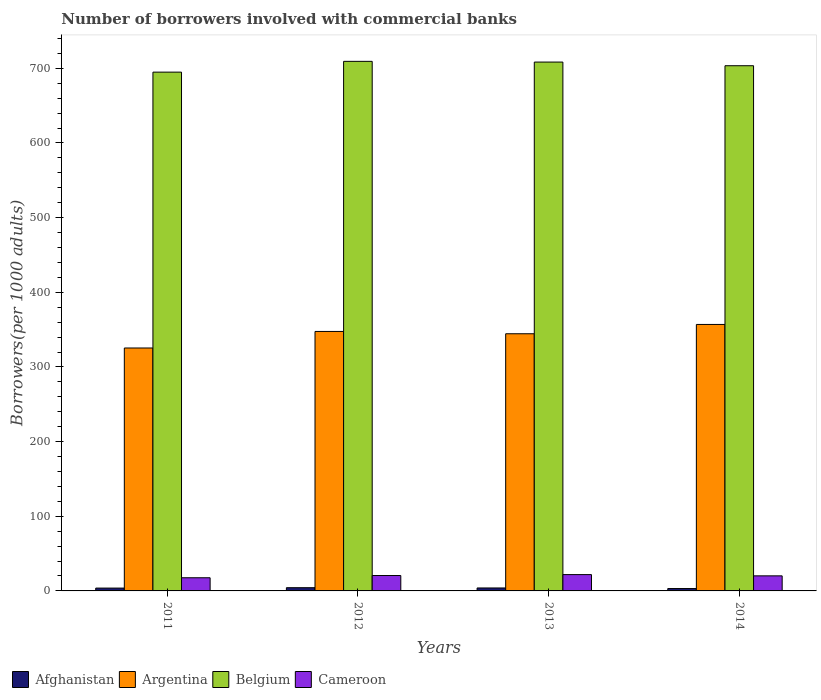Are the number of bars on each tick of the X-axis equal?
Your answer should be very brief. Yes. What is the number of borrowers involved with commercial banks in Belgium in 2012?
Ensure brevity in your answer.  709.35. Across all years, what is the maximum number of borrowers involved with commercial banks in Belgium?
Ensure brevity in your answer.  709.35. Across all years, what is the minimum number of borrowers involved with commercial banks in Belgium?
Your response must be concise. 694.92. In which year was the number of borrowers involved with commercial banks in Argentina minimum?
Provide a succinct answer. 2011. What is the total number of borrowers involved with commercial banks in Argentina in the graph?
Keep it short and to the point. 1374.36. What is the difference between the number of borrowers involved with commercial banks in Cameroon in 2011 and that in 2013?
Offer a terse response. -4.23. What is the difference between the number of borrowers involved with commercial banks in Argentina in 2011 and the number of borrowers involved with commercial banks in Belgium in 2014?
Keep it short and to the point. -378.09. What is the average number of borrowers involved with commercial banks in Belgium per year?
Your answer should be very brief. 704.03. In the year 2012, what is the difference between the number of borrowers involved with commercial banks in Afghanistan and number of borrowers involved with commercial banks in Belgium?
Your answer should be compact. -705.03. In how many years, is the number of borrowers involved with commercial banks in Argentina greater than 460?
Your answer should be very brief. 0. What is the ratio of the number of borrowers involved with commercial banks in Cameroon in 2011 to that in 2012?
Your answer should be compact. 0.85. Is the difference between the number of borrowers involved with commercial banks in Afghanistan in 2011 and 2012 greater than the difference between the number of borrowers involved with commercial banks in Belgium in 2011 and 2012?
Your answer should be compact. Yes. What is the difference between the highest and the second highest number of borrowers involved with commercial banks in Cameroon?
Provide a short and direct response. 1.23. What is the difference between the highest and the lowest number of borrowers involved with commercial banks in Afghanistan?
Your answer should be compact. 1.12. In how many years, is the number of borrowers involved with commercial banks in Argentina greater than the average number of borrowers involved with commercial banks in Argentina taken over all years?
Ensure brevity in your answer.  3. Is the sum of the number of borrowers involved with commercial banks in Argentina in 2011 and 2014 greater than the maximum number of borrowers involved with commercial banks in Afghanistan across all years?
Provide a short and direct response. Yes. What does the 3rd bar from the left in 2013 represents?
Your answer should be compact. Belgium. What does the 4th bar from the right in 2012 represents?
Offer a terse response. Afghanistan. How many bars are there?
Your answer should be compact. 16. What is the difference between two consecutive major ticks on the Y-axis?
Your response must be concise. 100. Are the values on the major ticks of Y-axis written in scientific E-notation?
Your answer should be very brief. No. Does the graph contain any zero values?
Provide a short and direct response. No. Does the graph contain grids?
Your answer should be compact. No. How many legend labels are there?
Give a very brief answer. 4. What is the title of the graph?
Make the answer very short. Number of borrowers involved with commercial banks. Does "Belgium" appear as one of the legend labels in the graph?
Offer a very short reply. Yes. What is the label or title of the Y-axis?
Provide a short and direct response. Borrowers(per 1000 adults). What is the Borrowers(per 1000 adults) of Afghanistan in 2011?
Your answer should be very brief. 3.79. What is the Borrowers(per 1000 adults) in Argentina in 2011?
Provide a short and direct response. 325.39. What is the Borrowers(per 1000 adults) of Belgium in 2011?
Provide a short and direct response. 694.92. What is the Borrowers(per 1000 adults) of Cameroon in 2011?
Offer a very short reply. 17.62. What is the Borrowers(per 1000 adults) in Afghanistan in 2012?
Offer a very short reply. 4.31. What is the Borrowers(per 1000 adults) of Argentina in 2012?
Keep it short and to the point. 347.56. What is the Borrowers(per 1000 adults) in Belgium in 2012?
Your response must be concise. 709.35. What is the Borrowers(per 1000 adults) of Cameroon in 2012?
Your response must be concise. 20.63. What is the Borrowers(per 1000 adults) of Afghanistan in 2013?
Make the answer very short. 3.96. What is the Borrowers(per 1000 adults) in Argentina in 2013?
Give a very brief answer. 344.47. What is the Borrowers(per 1000 adults) of Belgium in 2013?
Make the answer very short. 708.39. What is the Borrowers(per 1000 adults) of Cameroon in 2013?
Provide a short and direct response. 21.86. What is the Borrowers(per 1000 adults) of Afghanistan in 2014?
Offer a terse response. 3.2. What is the Borrowers(per 1000 adults) of Argentina in 2014?
Make the answer very short. 356.93. What is the Borrowers(per 1000 adults) of Belgium in 2014?
Ensure brevity in your answer.  703.48. What is the Borrowers(per 1000 adults) of Cameroon in 2014?
Keep it short and to the point. 20.18. Across all years, what is the maximum Borrowers(per 1000 adults) of Afghanistan?
Ensure brevity in your answer.  4.31. Across all years, what is the maximum Borrowers(per 1000 adults) in Argentina?
Offer a very short reply. 356.93. Across all years, what is the maximum Borrowers(per 1000 adults) in Belgium?
Your response must be concise. 709.35. Across all years, what is the maximum Borrowers(per 1000 adults) in Cameroon?
Your answer should be very brief. 21.86. Across all years, what is the minimum Borrowers(per 1000 adults) in Afghanistan?
Give a very brief answer. 3.2. Across all years, what is the minimum Borrowers(per 1000 adults) in Argentina?
Provide a succinct answer. 325.39. Across all years, what is the minimum Borrowers(per 1000 adults) of Belgium?
Your answer should be compact. 694.92. Across all years, what is the minimum Borrowers(per 1000 adults) in Cameroon?
Make the answer very short. 17.62. What is the total Borrowers(per 1000 adults) of Afghanistan in the graph?
Keep it short and to the point. 15.26. What is the total Borrowers(per 1000 adults) in Argentina in the graph?
Your answer should be very brief. 1374.36. What is the total Borrowers(per 1000 adults) in Belgium in the graph?
Provide a succinct answer. 2816.13. What is the total Borrowers(per 1000 adults) in Cameroon in the graph?
Your answer should be compact. 80.29. What is the difference between the Borrowers(per 1000 adults) of Afghanistan in 2011 and that in 2012?
Your answer should be very brief. -0.52. What is the difference between the Borrowers(per 1000 adults) in Argentina in 2011 and that in 2012?
Keep it short and to the point. -22.17. What is the difference between the Borrowers(per 1000 adults) of Belgium in 2011 and that in 2012?
Provide a short and direct response. -14.43. What is the difference between the Borrowers(per 1000 adults) of Cameroon in 2011 and that in 2012?
Provide a succinct answer. -3.01. What is the difference between the Borrowers(per 1000 adults) in Afghanistan in 2011 and that in 2013?
Your answer should be compact. -0.16. What is the difference between the Borrowers(per 1000 adults) in Argentina in 2011 and that in 2013?
Your response must be concise. -19.08. What is the difference between the Borrowers(per 1000 adults) of Belgium in 2011 and that in 2013?
Keep it short and to the point. -13.48. What is the difference between the Borrowers(per 1000 adults) of Cameroon in 2011 and that in 2013?
Offer a very short reply. -4.23. What is the difference between the Borrowers(per 1000 adults) in Afghanistan in 2011 and that in 2014?
Provide a short and direct response. 0.6. What is the difference between the Borrowers(per 1000 adults) of Argentina in 2011 and that in 2014?
Ensure brevity in your answer.  -31.54. What is the difference between the Borrowers(per 1000 adults) of Belgium in 2011 and that in 2014?
Ensure brevity in your answer.  -8.56. What is the difference between the Borrowers(per 1000 adults) in Cameroon in 2011 and that in 2014?
Your answer should be compact. -2.56. What is the difference between the Borrowers(per 1000 adults) of Afghanistan in 2012 and that in 2013?
Your answer should be compact. 0.36. What is the difference between the Borrowers(per 1000 adults) of Argentina in 2012 and that in 2013?
Your answer should be compact. 3.09. What is the difference between the Borrowers(per 1000 adults) of Belgium in 2012 and that in 2013?
Offer a very short reply. 0.95. What is the difference between the Borrowers(per 1000 adults) in Cameroon in 2012 and that in 2013?
Your answer should be very brief. -1.23. What is the difference between the Borrowers(per 1000 adults) in Afghanistan in 2012 and that in 2014?
Make the answer very short. 1.12. What is the difference between the Borrowers(per 1000 adults) in Argentina in 2012 and that in 2014?
Offer a terse response. -9.37. What is the difference between the Borrowers(per 1000 adults) of Belgium in 2012 and that in 2014?
Your response must be concise. 5.87. What is the difference between the Borrowers(per 1000 adults) in Cameroon in 2012 and that in 2014?
Your answer should be compact. 0.45. What is the difference between the Borrowers(per 1000 adults) of Afghanistan in 2013 and that in 2014?
Provide a succinct answer. 0.76. What is the difference between the Borrowers(per 1000 adults) of Argentina in 2013 and that in 2014?
Ensure brevity in your answer.  -12.46. What is the difference between the Borrowers(per 1000 adults) of Belgium in 2013 and that in 2014?
Offer a terse response. 4.92. What is the difference between the Borrowers(per 1000 adults) of Cameroon in 2013 and that in 2014?
Offer a very short reply. 1.68. What is the difference between the Borrowers(per 1000 adults) in Afghanistan in 2011 and the Borrowers(per 1000 adults) in Argentina in 2012?
Give a very brief answer. -343.76. What is the difference between the Borrowers(per 1000 adults) of Afghanistan in 2011 and the Borrowers(per 1000 adults) of Belgium in 2012?
Offer a very short reply. -705.55. What is the difference between the Borrowers(per 1000 adults) in Afghanistan in 2011 and the Borrowers(per 1000 adults) in Cameroon in 2012?
Your answer should be very brief. -16.84. What is the difference between the Borrowers(per 1000 adults) of Argentina in 2011 and the Borrowers(per 1000 adults) of Belgium in 2012?
Provide a short and direct response. -383.95. What is the difference between the Borrowers(per 1000 adults) in Argentina in 2011 and the Borrowers(per 1000 adults) in Cameroon in 2012?
Provide a succinct answer. 304.76. What is the difference between the Borrowers(per 1000 adults) of Belgium in 2011 and the Borrowers(per 1000 adults) of Cameroon in 2012?
Your answer should be compact. 674.28. What is the difference between the Borrowers(per 1000 adults) of Afghanistan in 2011 and the Borrowers(per 1000 adults) of Argentina in 2013?
Ensure brevity in your answer.  -340.68. What is the difference between the Borrowers(per 1000 adults) of Afghanistan in 2011 and the Borrowers(per 1000 adults) of Belgium in 2013?
Your response must be concise. -704.6. What is the difference between the Borrowers(per 1000 adults) in Afghanistan in 2011 and the Borrowers(per 1000 adults) in Cameroon in 2013?
Provide a succinct answer. -18.06. What is the difference between the Borrowers(per 1000 adults) in Argentina in 2011 and the Borrowers(per 1000 adults) in Belgium in 2013?
Your answer should be compact. -383. What is the difference between the Borrowers(per 1000 adults) in Argentina in 2011 and the Borrowers(per 1000 adults) in Cameroon in 2013?
Your answer should be compact. 303.53. What is the difference between the Borrowers(per 1000 adults) of Belgium in 2011 and the Borrowers(per 1000 adults) of Cameroon in 2013?
Offer a very short reply. 673.06. What is the difference between the Borrowers(per 1000 adults) in Afghanistan in 2011 and the Borrowers(per 1000 adults) in Argentina in 2014?
Offer a very short reply. -353.14. What is the difference between the Borrowers(per 1000 adults) in Afghanistan in 2011 and the Borrowers(per 1000 adults) in Belgium in 2014?
Offer a very short reply. -699.68. What is the difference between the Borrowers(per 1000 adults) of Afghanistan in 2011 and the Borrowers(per 1000 adults) of Cameroon in 2014?
Offer a very short reply. -16.39. What is the difference between the Borrowers(per 1000 adults) of Argentina in 2011 and the Borrowers(per 1000 adults) of Belgium in 2014?
Your answer should be compact. -378.09. What is the difference between the Borrowers(per 1000 adults) in Argentina in 2011 and the Borrowers(per 1000 adults) in Cameroon in 2014?
Your answer should be compact. 305.21. What is the difference between the Borrowers(per 1000 adults) in Belgium in 2011 and the Borrowers(per 1000 adults) in Cameroon in 2014?
Keep it short and to the point. 674.73. What is the difference between the Borrowers(per 1000 adults) of Afghanistan in 2012 and the Borrowers(per 1000 adults) of Argentina in 2013?
Give a very brief answer. -340.16. What is the difference between the Borrowers(per 1000 adults) in Afghanistan in 2012 and the Borrowers(per 1000 adults) in Belgium in 2013?
Offer a very short reply. -704.08. What is the difference between the Borrowers(per 1000 adults) of Afghanistan in 2012 and the Borrowers(per 1000 adults) of Cameroon in 2013?
Provide a succinct answer. -17.54. What is the difference between the Borrowers(per 1000 adults) in Argentina in 2012 and the Borrowers(per 1000 adults) in Belgium in 2013?
Make the answer very short. -360.83. What is the difference between the Borrowers(per 1000 adults) of Argentina in 2012 and the Borrowers(per 1000 adults) of Cameroon in 2013?
Your answer should be very brief. 325.7. What is the difference between the Borrowers(per 1000 adults) in Belgium in 2012 and the Borrowers(per 1000 adults) in Cameroon in 2013?
Make the answer very short. 687.49. What is the difference between the Borrowers(per 1000 adults) in Afghanistan in 2012 and the Borrowers(per 1000 adults) in Argentina in 2014?
Offer a very short reply. -352.62. What is the difference between the Borrowers(per 1000 adults) of Afghanistan in 2012 and the Borrowers(per 1000 adults) of Belgium in 2014?
Offer a very short reply. -699.17. What is the difference between the Borrowers(per 1000 adults) of Afghanistan in 2012 and the Borrowers(per 1000 adults) of Cameroon in 2014?
Give a very brief answer. -15.87. What is the difference between the Borrowers(per 1000 adults) of Argentina in 2012 and the Borrowers(per 1000 adults) of Belgium in 2014?
Make the answer very short. -355.92. What is the difference between the Borrowers(per 1000 adults) in Argentina in 2012 and the Borrowers(per 1000 adults) in Cameroon in 2014?
Provide a succinct answer. 327.38. What is the difference between the Borrowers(per 1000 adults) of Belgium in 2012 and the Borrowers(per 1000 adults) of Cameroon in 2014?
Your response must be concise. 689.16. What is the difference between the Borrowers(per 1000 adults) in Afghanistan in 2013 and the Borrowers(per 1000 adults) in Argentina in 2014?
Offer a terse response. -352.97. What is the difference between the Borrowers(per 1000 adults) in Afghanistan in 2013 and the Borrowers(per 1000 adults) in Belgium in 2014?
Your answer should be very brief. -699.52. What is the difference between the Borrowers(per 1000 adults) in Afghanistan in 2013 and the Borrowers(per 1000 adults) in Cameroon in 2014?
Ensure brevity in your answer.  -16.22. What is the difference between the Borrowers(per 1000 adults) in Argentina in 2013 and the Borrowers(per 1000 adults) in Belgium in 2014?
Provide a short and direct response. -359.01. What is the difference between the Borrowers(per 1000 adults) of Argentina in 2013 and the Borrowers(per 1000 adults) of Cameroon in 2014?
Your response must be concise. 324.29. What is the difference between the Borrowers(per 1000 adults) of Belgium in 2013 and the Borrowers(per 1000 adults) of Cameroon in 2014?
Ensure brevity in your answer.  688.21. What is the average Borrowers(per 1000 adults) in Afghanistan per year?
Give a very brief answer. 3.82. What is the average Borrowers(per 1000 adults) of Argentina per year?
Give a very brief answer. 343.59. What is the average Borrowers(per 1000 adults) in Belgium per year?
Your answer should be very brief. 704.03. What is the average Borrowers(per 1000 adults) in Cameroon per year?
Your response must be concise. 20.07. In the year 2011, what is the difference between the Borrowers(per 1000 adults) in Afghanistan and Borrowers(per 1000 adults) in Argentina?
Your answer should be compact. -321.6. In the year 2011, what is the difference between the Borrowers(per 1000 adults) in Afghanistan and Borrowers(per 1000 adults) in Belgium?
Provide a short and direct response. -691.12. In the year 2011, what is the difference between the Borrowers(per 1000 adults) in Afghanistan and Borrowers(per 1000 adults) in Cameroon?
Your answer should be compact. -13.83. In the year 2011, what is the difference between the Borrowers(per 1000 adults) in Argentina and Borrowers(per 1000 adults) in Belgium?
Provide a short and direct response. -369.52. In the year 2011, what is the difference between the Borrowers(per 1000 adults) of Argentina and Borrowers(per 1000 adults) of Cameroon?
Offer a very short reply. 307.77. In the year 2011, what is the difference between the Borrowers(per 1000 adults) of Belgium and Borrowers(per 1000 adults) of Cameroon?
Make the answer very short. 677.29. In the year 2012, what is the difference between the Borrowers(per 1000 adults) of Afghanistan and Borrowers(per 1000 adults) of Argentina?
Provide a short and direct response. -343.25. In the year 2012, what is the difference between the Borrowers(per 1000 adults) of Afghanistan and Borrowers(per 1000 adults) of Belgium?
Make the answer very short. -705.03. In the year 2012, what is the difference between the Borrowers(per 1000 adults) in Afghanistan and Borrowers(per 1000 adults) in Cameroon?
Make the answer very short. -16.32. In the year 2012, what is the difference between the Borrowers(per 1000 adults) of Argentina and Borrowers(per 1000 adults) of Belgium?
Keep it short and to the point. -361.79. In the year 2012, what is the difference between the Borrowers(per 1000 adults) in Argentina and Borrowers(per 1000 adults) in Cameroon?
Make the answer very short. 326.93. In the year 2012, what is the difference between the Borrowers(per 1000 adults) of Belgium and Borrowers(per 1000 adults) of Cameroon?
Provide a succinct answer. 688.72. In the year 2013, what is the difference between the Borrowers(per 1000 adults) in Afghanistan and Borrowers(per 1000 adults) in Argentina?
Provide a short and direct response. -340.52. In the year 2013, what is the difference between the Borrowers(per 1000 adults) in Afghanistan and Borrowers(per 1000 adults) in Belgium?
Your answer should be compact. -704.44. In the year 2013, what is the difference between the Borrowers(per 1000 adults) in Afghanistan and Borrowers(per 1000 adults) in Cameroon?
Give a very brief answer. -17.9. In the year 2013, what is the difference between the Borrowers(per 1000 adults) of Argentina and Borrowers(per 1000 adults) of Belgium?
Provide a succinct answer. -363.92. In the year 2013, what is the difference between the Borrowers(per 1000 adults) of Argentina and Borrowers(per 1000 adults) of Cameroon?
Your answer should be compact. 322.62. In the year 2013, what is the difference between the Borrowers(per 1000 adults) in Belgium and Borrowers(per 1000 adults) in Cameroon?
Offer a terse response. 686.54. In the year 2014, what is the difference between the Borrowers(per 1000 adults) in Afghanistan and Borrowers(per 1000 adults) in Argentina?
Make the answer very short. -353.73. In the year 2014, what is the difference between the Borrowers(per 1000 adults) of Afghanistan and Borrowers(per 1000 adults) of Belgium?
Your answer should be compact. -700.28. In the year 2014, what is the difference between the Borrowers(per 1000 adults) of Afghanistan and Borrowers(per 1000 adults) of Cameroon?
Offer a terse response. -16.98. In the year 2014, what is the difference between the Borrowers(per 1000 adults) of Argentina and Borrowers(per 1000 adults) of Belgium?
Provide a succinct answer. -346.55. In the year 2014, what is the difference between the Borrowers(per 1000 adults) in Argentina and Borrowers(per 1000 adults) in Cameroon?
Keep it short and to the point. 336.75. In the year 2014, what is the difference between the Borrowers(per 1000 adults) in Belgium and Borrowers(per 1000 adults) in Cameroon?
Make the answer very short. 683.3. What is the ratio of the Borrowers(per 1000 adults) in Afghanistan in 2011 to that in 2012?
Provide a short and direct response. 0.88. What is the ratio of the Borrowers(per 1000 adults) of Argentina in 2011 to that in 2012?
Your answer should be compact. 0.94. What is the ratio of the Borrowers(per 1000 adults) of Belgium in 2011 to that in 2012?
Your answer should be very brief. 0.98. What is the ratio of the Borrowers(per 1000 adults) in Cameroon in 2011 to that in 2012?
Ensure brevity in your answer.  0.85. What is the ratio of the Borrowers(per 1000 adults) of Afghanistan in 2011 to that in 2013?
Provide a short and direct response. 0.96. What is the ratio of the Borrowers(per 1000 adults) in Argentina in 2011 to that in 2013?
Keep it short and to the point. 0.94. What is the ratio of the Borrowers(per 1000 adults) in Cameroon in 2011 to that in 2013?
Keep it short and to the point. 0.81. What is the ratio of the Borrowers(per 1000 adults) in Afghanistan in 2011 to that in 2014?
Keep it short and to the point. 1.19. What is the ratio of the Borrowers(per 1000 adults) of Argentina in 2011 to that in 2014?
Your response must be concise. 0.91. What is the ratio of the Borrowers(per 1000 adults) in Belgium in 2011 to that in 2014?
Give a very brief answer. 0.99. What is the ratio of the Borrowers(per 1000 adults) in Cameroon in 2011 to that in 2014?
Keep it short and to the point. 0.87. What is the ratio of the Borrowers(per 1000 adults) of Afghanistan in 2012 to that in 2013?
Ensure brevity in your answer.  1.09. What is the ratio of the Borrowers(per 1000 adults) of Belgium in 2012 to that in 2013?
Provide a short and direct response. 1. What is the ratio of the Borrowers(per 1000 adults) in Cameroon in 2012 to that in 2013?
Keep it short and to the point. 0.94. What is the ratio of the Borrowers(per 1000 adults) in Afghanistan in 2012 to that in 2014?
Offer a very short reply. 1.35. What is the ratio of the Borrowers(per 1000 adults) of Argentina in 2012 to that in 2014?
Your answer should be compact. 0.97. What is the ratio of the Borrowers(per 1000 adults) in Belgium in 2012 to that in 2014?
Provide a short and direct response. 1.01. What is the ratio of the Borrowers(per 1000 adults) of Cameroon in 2012 to that in 2014?
Offer a very short reply. 1.02. What is the ratio of the Borrowers(per 1000 adults) in Afghanistan in 2013 to that in 2014?
Provide a succinct answer. 1.24. What is the ratio of the Borrowers(per 1000 adults) in Argentina in 2013 to that in 2014?
Make the answer very short. 0.97. What is the ratio of the Borrowers(per 1000 adults) of Belgium in 2013 to that in 2014?
Make the answer very short. 1.01. What is the ratio of the Borrowers(per 1000 adults) of Cameroon in 2013 to that in 2014?
Give a very brief answer. 1.08. What is the difference between the highest and the second highest Borrowers(per 1000 adults) of Afghanistan?
Provide a succinct answer. 0.36. What is the difference between the highest and the second highest Borrowers(per 1000 adults) of Argentina?
Your answer should be very brief. 9.37. What is the difference between the highest and the second highest Borrowers(per 1000 adults) of Belgium?
Give a very brief answer. 0.95. What is the difference between the highest and the second highest Borrowers(per 1000 adults) of Cameroon?
Offer a very short reply. 1.23. What is the difference between the highest and the lowest Borrowers(per 1000 adults) in Afghanistan?
Your answer should be very brief. 1.12. What is the difference between the highest and the lowest Borrowers(per 1000 adults) in Argentina?
Your answer should be compact. 31.54. What is the difference between the highest and the lowest Borrowers(per 1000 adults) of Belgium?
Offer a terse response. 14.43. What is the difference between the highest and the lowest Borrowers(per 1000 adults) of Cameroon?
Your response must be concise. 4.23. 